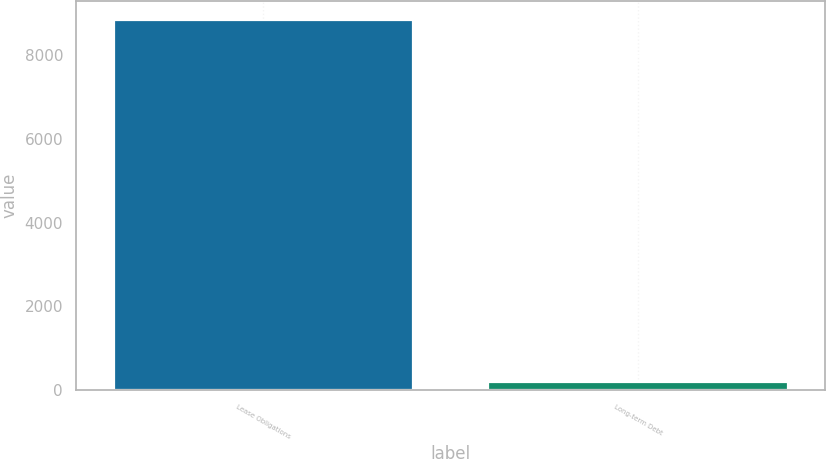Convert chart. <chart><loc_0><loc_0><loc_500><loc_500><bar_chart><fcel>Lease Obligations<fcel>Long-term Debt<nl><fcel>8846<fcel>187<nl></chart> 